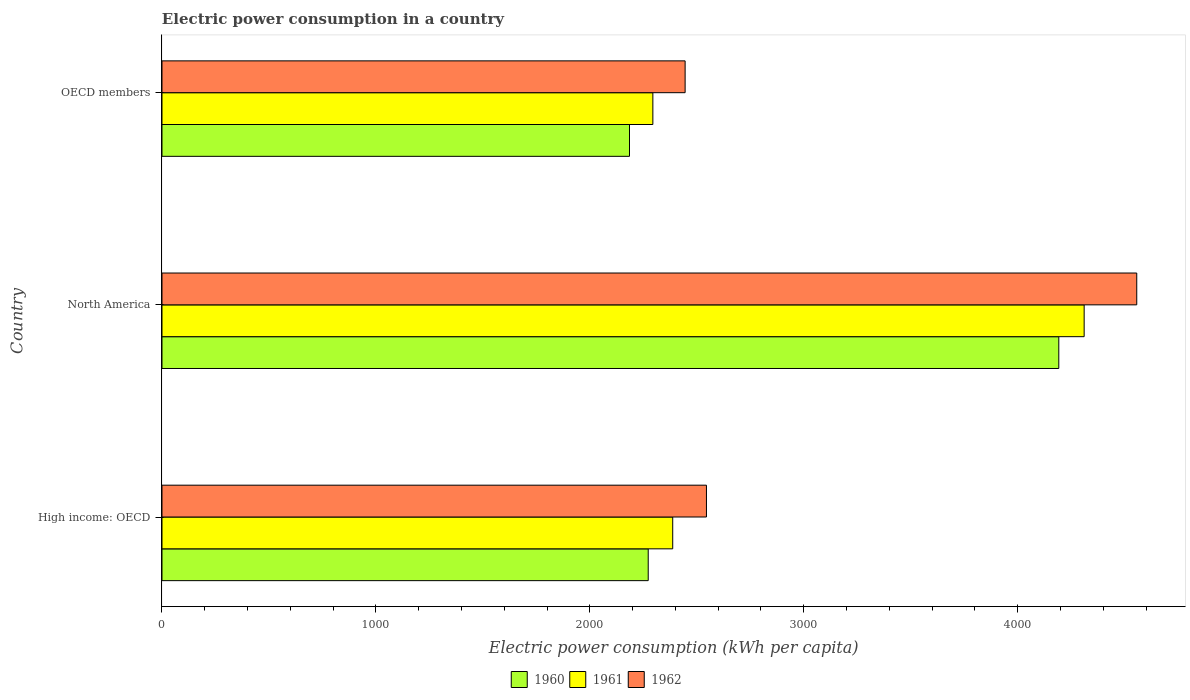Are the number of bars per tick equal to the number of legend labels?
Offer a terse response. Yes. How many bars are there on the 3rd tick from the top?
Provide a succinct answer. 3. How many bars are there on the 3rd tick from the bottom?
Ensure brevity in your answer.  3. What is the label of the 2nd group of bars from the top?
Make the answer very short. North America. In how many cases, is the number of bars for a given country not equal to the number of legend labels?
Offer a terse response. 0. What is the electric power consumption in in 1961 in North America?
Ensure brevity in your answer.  4310.91. Across all countries, what is the maximum electric power consumption in in 1960?
Provide a succinct answer. 4192.36. Across all countries, what is the minimum electric power consumption in in 1961?
Your answer should be very brief. 2294.73. In which country was the electric power consumption in in 1962 minimum?
Your response must be concise. OECD members. What is the total electric power consumption in in 1962 in the graph?
Keep it short and to the point. 9547.53. What is the difference between the electric power consumption in in 1961 in High income: OECD and that in North America?
Provide a short and direct response. -1923.4. What is the difference between the electric power consumption in in 1962 in High income: OECD and the electric power consumption in in 1961 in OECD members?
Ensure brevity in your answer.  250.5. What is the average electric power consumption in in 1962 per country?
Your answer should be very brief. 3182.51. What is the difference between the electric power consumption in in 1961 and electric power consumption in in 1960 in North America?
Give a very brief answer. 118.55. In how many countries, is the electric power consumption in in 1960 greater than 4200 kWh per capita?
Offer a very short reply. 0. What is the ratio of the electric power consumption in in 1961 in High income: OECD to that in North America?
Your answer should be very brief. 0.55. What is the difference between the highest and the second highest electric power consumption in in 1961?
Give a very brief answer. 1923.4. What is the difference between the highest and the lowest electric power consumption in in 1960?
Ensure brevity in your answer.  2006.82. In how many countries, is the electric power consumption in in 1961 greater than the average electric power consumption in in 1961 taken over all countries?
Provide a short and direct response. 1. Is the sum of the electric power consumption in in 1962 in High income: OECD and OECD members greater than the maximum electric power consumption in in 1960 across all countries?
Give a very brief answer. Yes. What does the 2nd bar from the bottom in High income: OECD represents?
Provide a short and direct response. 1961. Is it the case that in every country, the sum of the electric power consumption in in 1960 and electric power consumption in in 1961 is greater than the electric power consumption in in 1962?
Offer a very short reply. Yes. Are the values on the major ticks of X-axis written in scientific E-notation?
Provide a succinct answer. No. Does the graph contain any zero values?
Provide a succinct answer. No. Where does the legend appear in the graph?
Offer a very short reply. Bottom center. How many legend labels are there?
Your answer should be very brief. 3. How are the legend labels stacked?
Provide a succinct answer. Horizontal. What is the title of the graph?
Your answer should be very brief. Electric power consumption in a country. What is the label or title of the X-axis?
Your response must be concise. Electric power consumption (kWh per capita). What is the label or title of the Y-axis?
Your answer should be very brief. Country. What is the Electric power consumption (kWh per capita) of 1960 in High income: OECD?
Your response must be concise. 2272.98. What is the Electric power consumption (kWh per capita) in 1961 in High income: OECD?
Provide a short and direct response. 2387.51. What is the Electric power consumption (kWh per capita) in 1962 in High income: OECD?
Your answer should be compact. 2545.23. What is the Electric power consumption (kWh per capita) of 1960 in North America?
Give a very brief answer. 4192.36. What is the Electric power consumption (kWh per capita) in 1961 in North America?
Your answer should be very brief. 4310.91. What is the Electric power consumption (kWh per capita) in 1962 in North America?
Offer a terse response. 4556.78. What is the Electric power consumption (kWh per capita) of 1960 in OECD members?
Your response must be concise. 2185.53. What is the Electric power consumption (kWh per capita) in 1961 in OECD members?
Ensure brevity in your answer.  2294.73. What is the Electric power consumption (kWh per capita) of 1962 in OECD members?
Make the answer very short. 2445.52. Across all countries, what is the maximum Electric power consumption (kWh per capita) in 1960?
Your answer should be compact. 4192.36. Across all countries, what is the maximum Electric power consumption (kWh per capita) in 1961?
Make the answer very short. 4310.91. Across all countries, what is the maximum Electric power consumption (kWh per capita) in 1962?
Provide a succinct answer. 4556.78. Across all countries, what is the minimum Electric power consumption (kWh per capita) in 1960?
Offer a very short reply. 2185.53. Across all countries, what is the minimum Electric power consumption (kWh per capita) of 1961?
Make the answer very short. 2294.73. Across all countries, what is the minimum Electric power consumption (kWh per capita) in 1962?
Keep it short and to the point. 2445.52. What is the total Electric power consumption (kWh per capita) in 1960 in the graph?
Provide a short and direct response. 8650.86. What is the total Electric power consumption (kWh per capita) of 1961 in the graph?
Keep it short and to the point. 8993.14. What is the total Electric power consumption (kWh per capita) of 1962 in the graph?
Your response must be concise. 9547.53. What is the difference between the Electric power consumption (kWh per capita) in 1960 in High income: OECD and that in North America?
Offer a very short reply. -1919.38. What is the difference between the Electric power consumption (kWh per capita) of 1961 in High income: OECD and that in North America?
Your response must be concise. -1923.4. What is the difference between the Electric power consumption (kWh per capita) of 1962 in High income: OECD and that in North America?
Your response must be concise. -2011.55. What is the difference between the Electric power consumption (kWh per capita) of 1960 in High income: OECD and that in OECD members?
Provide a succinct answer. 87.44. What is the difference between the Electric power consumption (kWh per capita) of 1961 in High income: OECD and that in OECD members?
Your answer should be very brief. 92.77. What is the difference between the Electric power consumption (kWh per capita) of 1962 in High income: OECD and that in OECD members?
Your answer should be very brief. 99.71. What is the difference between the Electric power consumption (kWh per capita) in 1960 in North America and that in OECD members?
Make the answer very short. 2006.82. What is the difference between the Electric power consumption (kWh per capita) of 1961 in North America and that in OECD members?
Your response must be concise. 2016.17. What is the difference between the Electric power consumption (kWh per capita) in 1962 in North America and that in OECD members?
Offer a very short reply. 2111.25. What is the difference between the Electric power consumption (kWh per capita) of 1960 in High income: OECD and the Electric power consumption (kWh per capita) of 1961 in North America?
Your response must be concise. -2037.93. What is the difference between the Electric power consumption (kWh per capita) of 1960 in High income: OECD and the Electric power consumption (kWh per capita) of 1962 in North America?
Offer a very short reply. -2283.8. What is the difference between the Electric power consumption (kWh per capita) in 1961 in High income: OECD and the Electric power consumption (kWh per capita) in 1962 in North America?
Your response must be concise. -2169.27. What is the difference between the Electric power consumption (kWh per capita) of 1960 in High income: OECD and the Electric power consumption (kWh per capita) of 1961 in OECD members?
Offer a very short reply. -21.76. What is the difference between the Electric power consumption (kWh per capita) in 1960 in High income: OECD and the Electric power consumption (kWh per capita) in 1962 in OECD members?
Make the answer very short. -172.55. What is the difference between the Electric power consumption (kWh per capita) in 1961 in High income: OECD and the Electric power consumption (kWh per capita) in 1962 in OECD members?
Offer a very short reply. -58.02. What is the difference between the Electric power consumption (kWh per capita) in 1960 in North America and the Electric power consumption (kWh per capita) in 1961 in OECD members?
Provide a succinct answer. 1897.62. What is the difference between the Electric power consumption (kWh per capita) of 1960 in North America and the Electric power consumption (kWh per capita) of 1962 in OECD members?
Make the answer very short. 1746.83. What is the difference between the Electric power consumption (kWh per capita) of 1961 in North America and the Electric power consumption (kWh per capita) of 1962 in OECD members?
Offer a terse response. 1865.38. What is the average Electric power consumption (kWh per capita) in 1960 per country?
Offer a very short reply. 2883.62. What is the average Electric power consumption (kWh per capita) in 1961 per country?
Give a very brief answer. 2997.71. What is the average Electric power consumption (kWh per capita) in 1962 per country?
Ensure brevity in your answer.  3182.51. What is the difference between the Electric power consumption (kWh per capita) of 1960 and Electric power consumption (kWh per capita) of 1961 in High income: OECD?
Your response must be concise. -114.53. What is the difference between the Electric power consumption (kWh per capita) in 1960 and Electric power consumption (kWh per capita) in 1962 in High income: OECD?
Your answer should be compact. -272.26. What is the difference between the Electric power consumption (kWh per capita) in 1961 and Electric power consumption (kWh per capita) in 1962 in High income: OECD?
Ensure brevity in your answer.  -157.73. What is the difference between the Electric power consumption (kWh per capita) of 1960 and Electric power consumption (kWh per capita) of 1961 in North America?
Ensure brevity in your answer.  -118.55. What is the difference between the Electric power consumption (kWh per capita) of 1960 and Electric power consumption (kWh per capita) of 1962 in North America?
Your answer should be very brief. -364.42. What is the difference between the Electric power consumption (kWh per capita) of 1961 and Electric power consumption (kWh per capita) of 1962 in North America?
Make the answer very short. -245.87. What is the difference between the Electric power consumption (kWh per capita) of 1960 and Electric power consumption (kWh per capita) of 1961 in OECD members?
Your answer should be compact. -109.2. What is the difference between the Electric power consumption (kWh per capita) of 1960 and Electric power consumption (kWh per capita) of 1962 in OECD members?
Keep it short and to the point. -259.99. What is the difference between the Electric power consumption (kWh per capita) of 1961 and Electric power consumption (kWh per capita) of 1962 in OECD members?
Your response must be concise. -150.79. What is the ratio of the Electric power consumption (kWh per capita) of 1960 in High income: OECD to that in North America?
Provide a short and direct response. 0.54. What is the ratio of the Electric power consumption (kWh per capita) of 1961 in High income: OECD to that in North America?
Offer a terse response. 0.55. What is the ratio of the Electric power consumption (kWh per capita) of 1962 in High income: OECD to that in North America?
Offer a terse response. 0.56. What is the ratio of the Electric power consumption (kWh per capita) of 1961 in High income: OECD to that in OECD members?
Provide a short and direct response. 1.04. What is the ratio of the Electric power consumption (kWh per capita) in 1962 in High income: OECD to that in OECD members?
Offer a terse response. 1.04. What is the ratio of the Electric power consumption (kWh per capita) in 1960 in North America to that in OECD members?
Ensure brevity in your answer.  1.92. What is the ratio of the Electric power consumption (kWh per capita) of 1961 in North America to that in OECD members?
Make the answer very short. 1.88. What is the ratio of the Electric power consumption (kWh per capita) in 1962 in North America to that in OECD members?
Offer a terse response. 1.86. What is the difference between the highest and the second highest Electric power consumption (kWh per capita) of 1960?
Offer a very short reply. 1919.38. What is the difference between the highest and the second highest Electric power consumption (kWh per capita) in 1961?
Offer a terse response. 1923.4. What is the difference between the highest and the second highest Electric power consumption (kWh per capita) of 1962?
Your response must be concise. 2011.55. What is the difference between the highest and the lowest Electric power consumption (kWh per capita) of 1960?
Your response must be concise. 2006.82. What is the difference between the highest and the lowest Electric power consumption (kWh per capita) of 1961?
Keep it short and to the point. 2016.17. What is the difference between the highest and the lowest Electric power consumption (kWh per capita) of 1962?
Offer a terse response. 2111.25. 